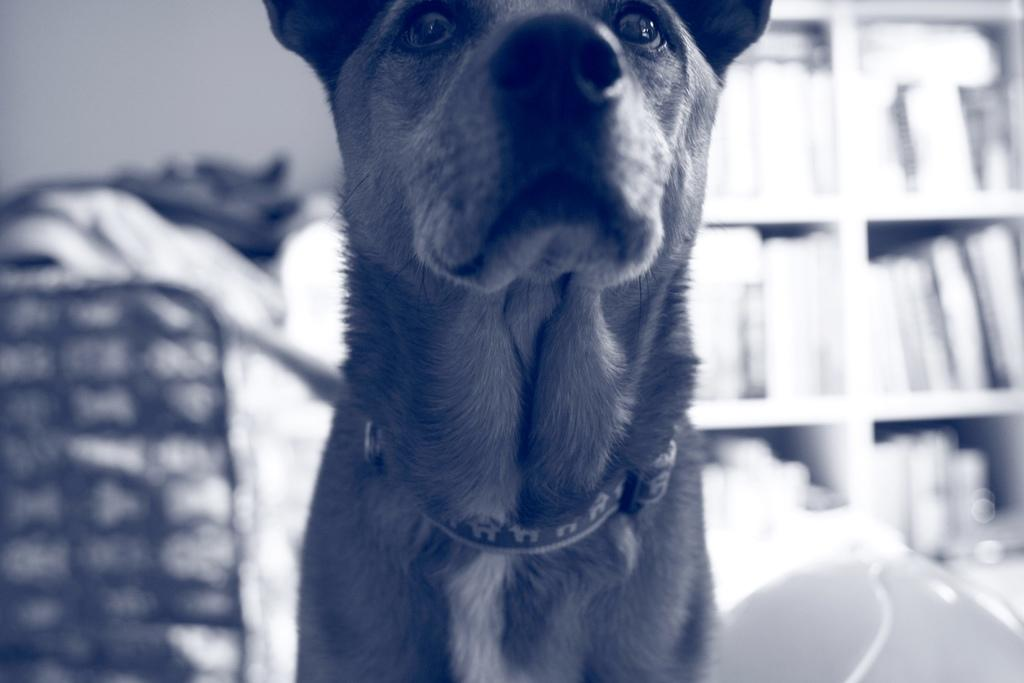What is the main subject of the image? There is a dog in the middle of the image. What can be said about the color scheme of the image? The image is in black and white color. What type of berry is the dog eating in the image? There is no berry present in the image, as it is in black and white color and does not show any food items. 